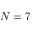Convert formula to latex. <formula><loc_0><loc_0><loc_500><loc_500>N = 7</formula> 